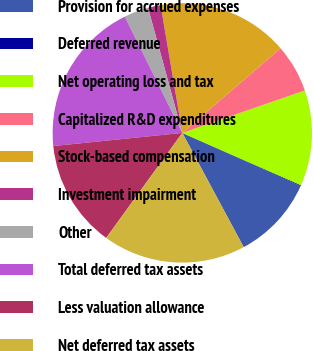<chart> <loc_0><loc_0><loc_500><loc_500><pie_chart><fcel>Provision for accrued expenses<fcel>Deferred revenue<fcel>Net operating loss and tax<fcel>Capitalized R&D expenditures<fcel>Stock-based compensation<fcel>Investment impairment<fcel>Other<fcel>Total deferred tax assets<fcel>Less valuation allowance<fcel>Net deferred tax assets<nl><fcel>10.44%<fcel>0.1%<fcel>11.92%<fcel>6.01%<fcel>16.36%<fcel>1.58%<fcel>3.05%<fcel>19.31%<fcel>13.4%<fcel>17.83%<nl></chart> 